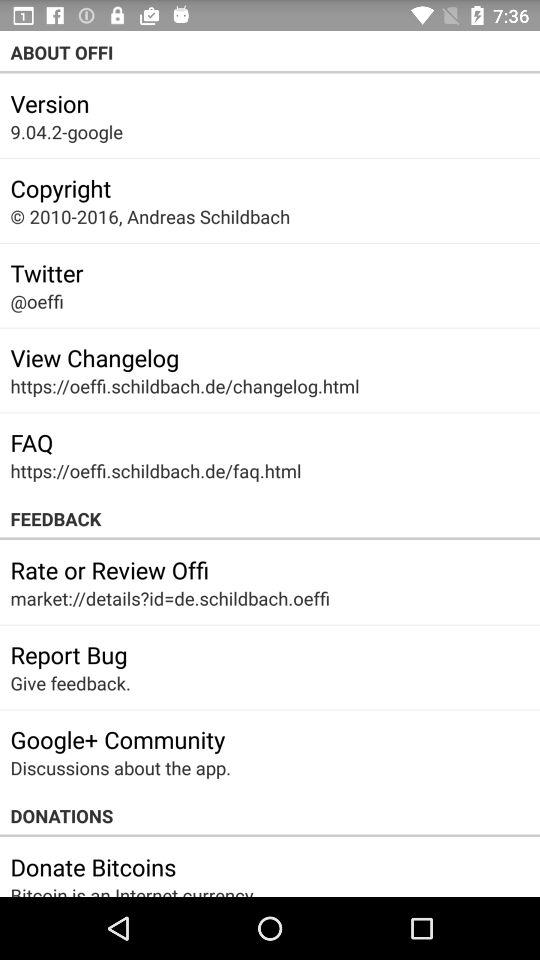What is the mentioned "Twitter" handle? The mentioned "Twitter" handle is "@oeffi". 